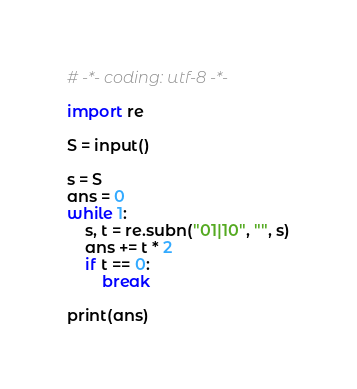Convert code to text. <code><loc_0><loc_0><loc_500><loc_500><_Python_># -*- coding: utf-8 -*-

import re

S = input()

s = S
ans = 0
while 1:
    s, t = re.subn("01|10", "", s)
    ans += t * 2
    if t == 0:
        break

print(ans)
</code> 